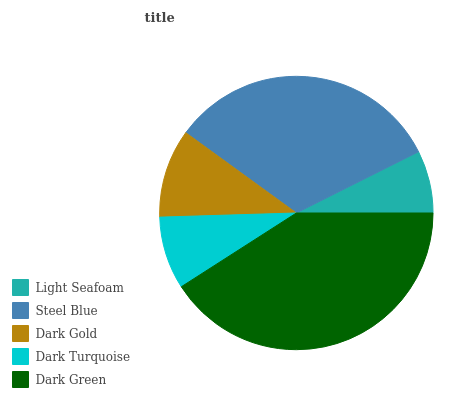Is Light Seafoam the minimum?
Answer yes or no. Yes. Is Dark Green the maximum?
Answer yes or no. Yes. Is Steel Blue the minimum?
Answer yes or no. No. Is Steel Blue the maximum?
Answer yes or no. No. Is Steel Blue greater than Light Seafoam?
Answer yes or no. Yes. Is Light Seafoam less than Steel Blue?
Answer yes or no. Yes. Is Light Seafoam greater than Steel Blue?
Answer yes or no. No. Is Steel Blue less than Light Seafoam?
Answer yes or no. No. Is Dark Gold the high median?
Answer yes or no. Yes. Is Dark Gold the low median?
Answer yes or no. Yes. Is Dark Turquoise the high median?
Answer yes or no. No. Is Dark Green the low median?
Answer yes or no. No. 